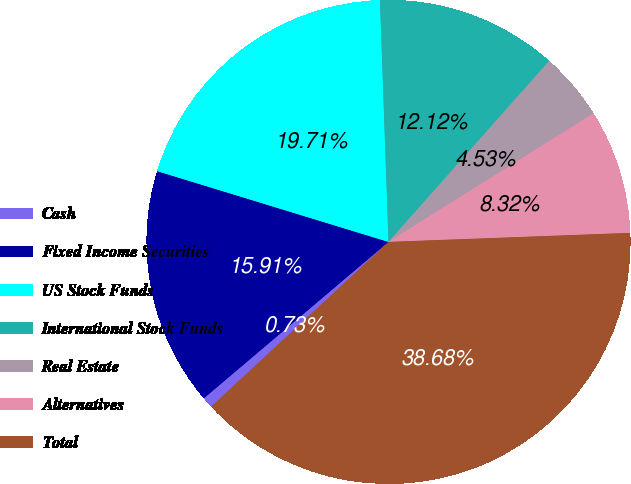<chart> <loc_0><loc_0><loc_500><loc_500><pie_chart><fcel>Cash<fcel>Fixed Income Securities<fcel>US Stock Funds<fcel>International Stock Funds<fcel>Real Estate<fcel>Alternatives<fcel>Total<nl><fcel>0.73%<fcel>15.91%<fcel>19.71%<fcel>12.12%<fcel>4.53%<fcel>8.32%<fcel>38.68%<nl></chart> 